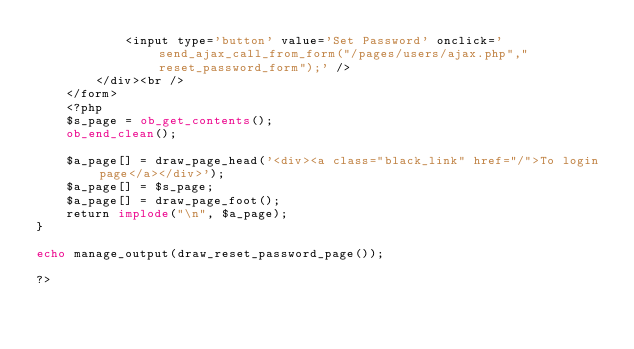<code> <loc_0><loc_0><loc_500><loc_500><_PHP_>			<input type='button' value='Set Password' onclick='send_ajax_call_from_form("/pages/users/ajax.php","reset_password_form");' />
		</div><br />
	</form>
	<?php
	$s_page = ob_get_contents();
	ob_end_clean();

	$a_page[] = draw_page_head('<div><a class="black_link" href="/">To login page</a></div>');
	$a_page[] = $s_page;
	$a_page[] = draw_page_foot();
	return implode("\n", $a_page);
}

echo manage_output(draw_reset_password_page());

?></code> 